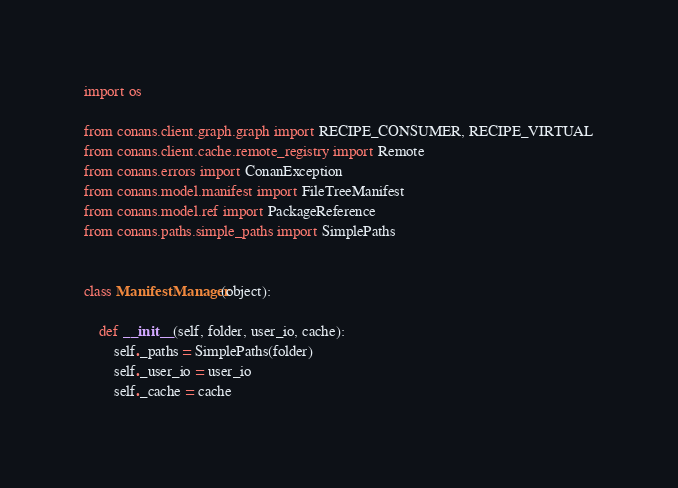<code> <loc_0><loc_0><loc_500><loc_500><_Python_>import os

from conans.client.graph.graph import RECIPE_CONSUMER, RECIPE_VIRTUAL
from conans.client.cache.remote_registry import Remote
from conans.errors import ConanException
from conans.model.manifest import FileTreeManifest
from conans.model.ref import PackageReference
from conans.paths.simple_paths import SimplePaths


class ManifestManager(object):

    def __init__(self, folder, user_io, cache):
        self._paths = SimplePaths(folder)
        self._user_io = user_io
        self._cache = cache</code> 